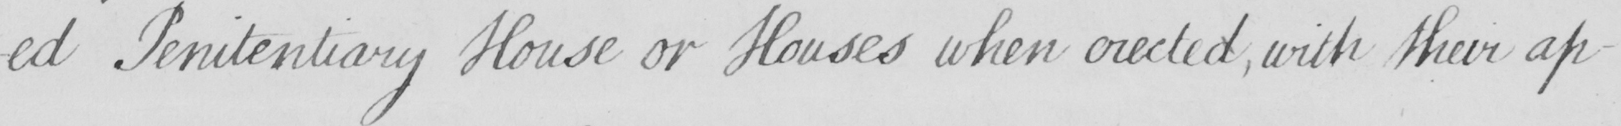What text is written in this handwritten line? -ed Penitentiary House or Houses when erected  , with their ap- 